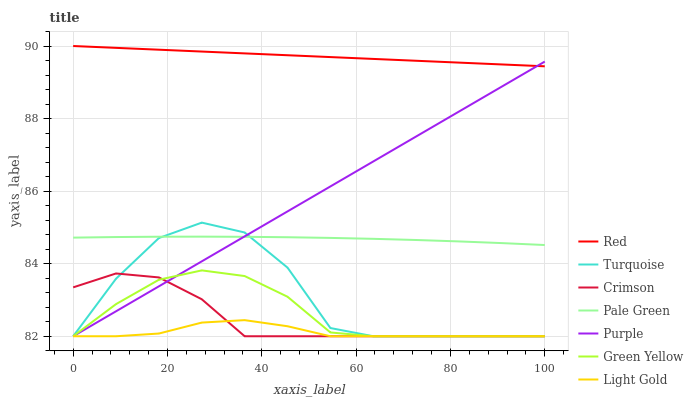Does Purple have the minimum area under the curve?
Answer yes or no. No. Does Purple have the maximum area under the curve?
Answer yes or no. No. Is Purple the smoothest?
Answer yes or no. No. Is Purple the roughest?
Answer yes or no. No. Does Pale Green have the lowest value?
Answer yes or no. No. Does Purple have the highest value?
Answer yes or no. No. Is Green Yellow less than Red?
Answer yes or no. Yes. Is Red greater than Turquoise?
Answer yes or no. Yes. Does Green Yellow intersect Red?
Answer yes or no. No. 